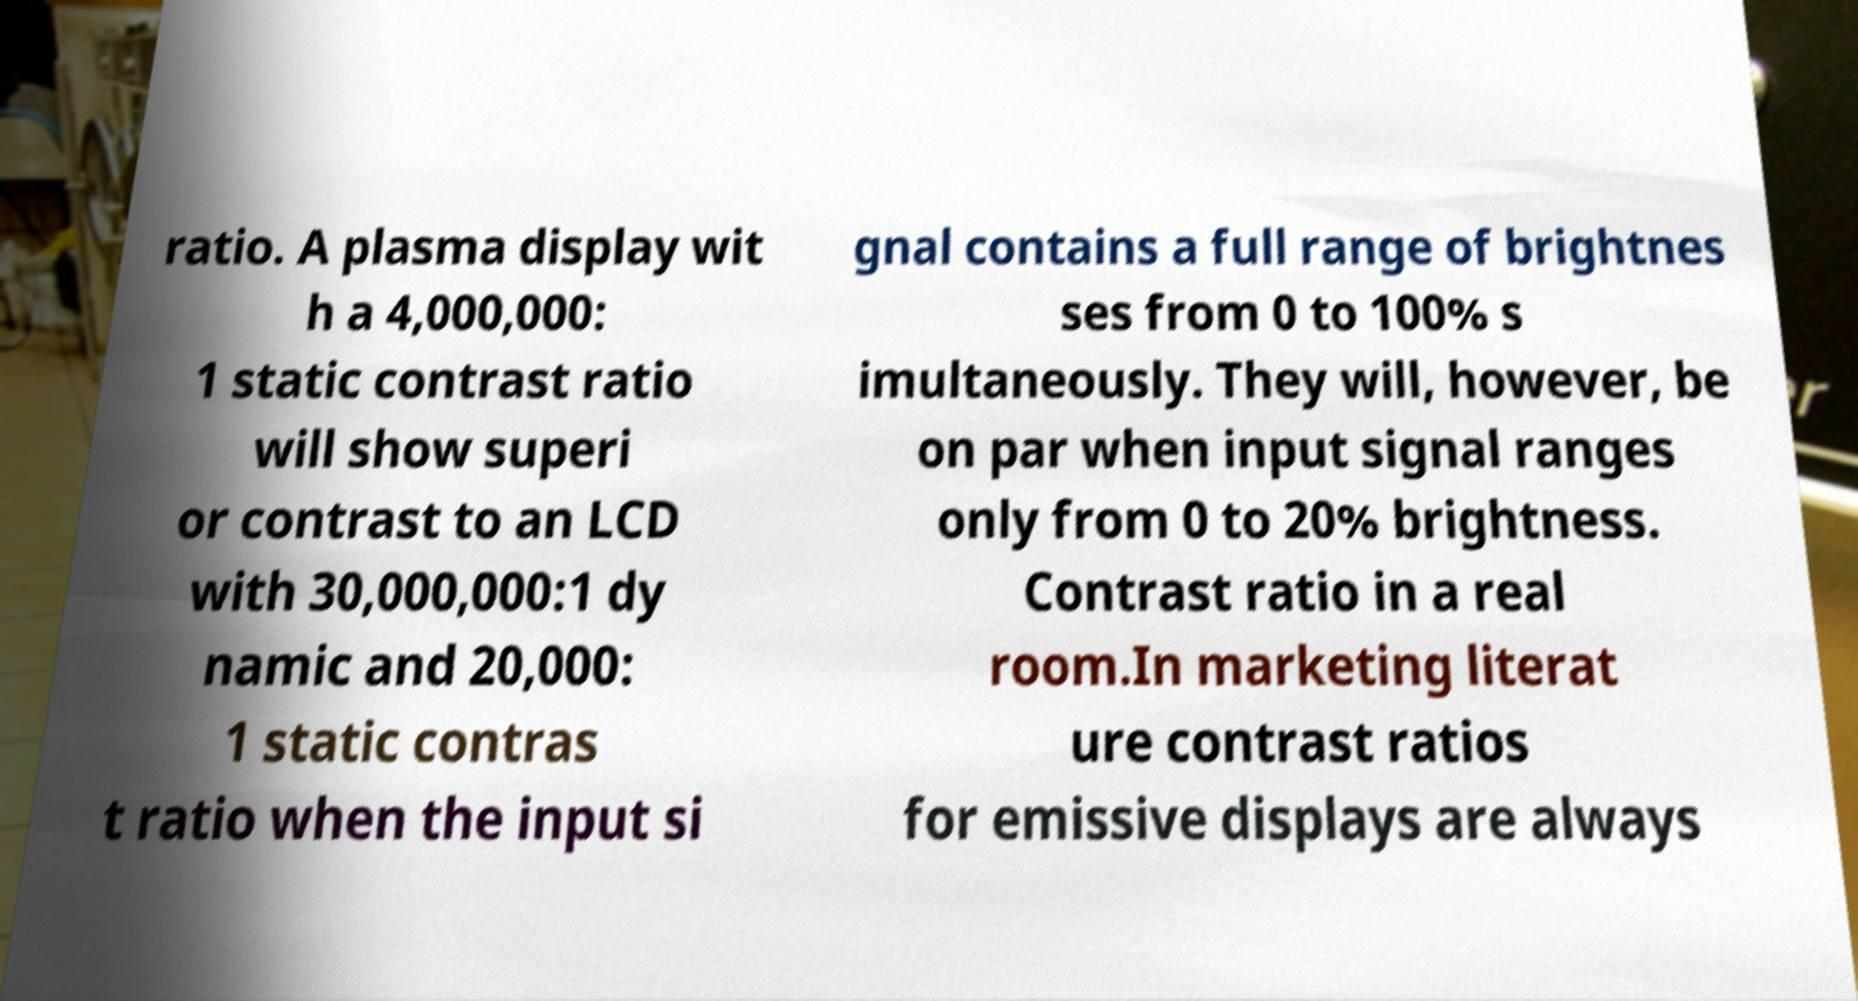Could you assist in decoding the text presented in this image and type it out clearly? ratio. A plasma display wit h a 4,000,000: 1 static contrast ratio will show superi or contrast to an LCD with 30,000,000:1 dy namic and 20,000: 1 static contras t ratio when the input si gnal contains a full range of brightnes ses from 0 to 100% s imultaneously. They will, however, be on par when input signal ranges only from 0 to 20% brightness. Contrast ratio in a real room.In marketing literat ure contrast ratios for emissive displays are always 